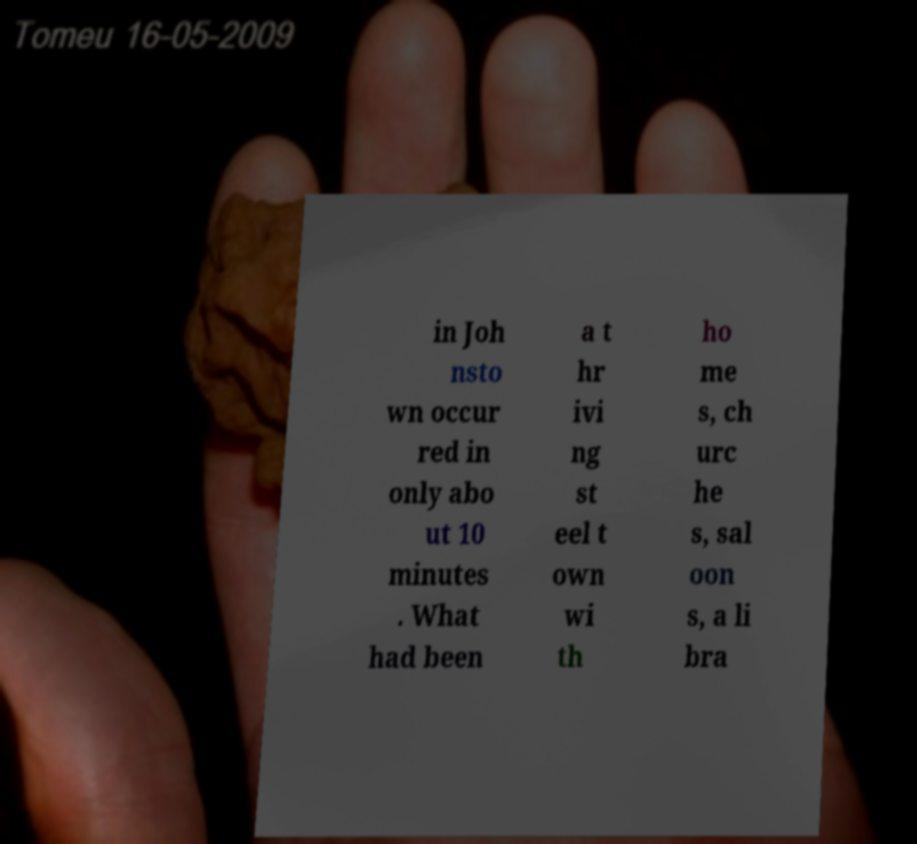Could you extract and type out the text from this image? in Joh nsto wn occur red in only abo ut 10 minutes . What had been a t hr ivi ng st eel t own wi th ho me s, ch urc he s, sal oon s, a li bra 